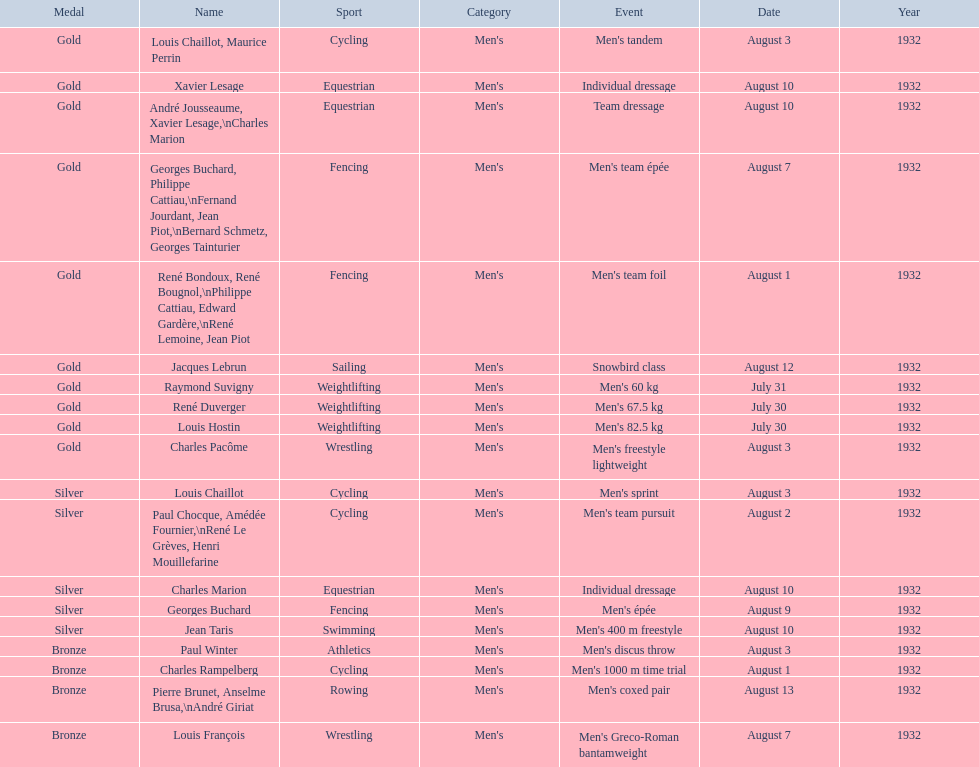How many gold medals did this country win during these olympics? 10. Would you be able to parse every entry in this table? {'header': ['Medal', 'Name', 'Sport', 'Category', 'Event', 'Date', 'Year'], 'rows': [['Gold', 'Louis Chaillot, Maurice Perrin', 'Cycling', "Men's", "Men's tandem", 'August 3', '1932'], ['Gold', 'Xavier Lesage', 'Equestrian', "Men's", 'Individual dressage', 'August 10', '1932'], ['Gold', 'André Jousseaume, Xavier Lesage,\\nCharles Marion', 'Equestrian', "Men's", 'Team dressage', 'August 10', '1932'], ['Gold', 'Georges Buchard, Philippe Cattiau,\\nFernand Jourdant, Jean Piot,\\nBernard Schmetz, Georges Tainturier', 'Fencing', "Men's", "Men's team épée", 'August 7', '1932'], ['Gold', 'René Bondoux, René Bougnol,\\nPhilippe Cattiau, Edward Gardère,\\nRené Lemoine, Jean Piot', 'Fencing', "Men's", "Men's team foil", 'August 1', '1932'], ['Gold', 'Jacques Lebrun', 'Sailing', "Men's", 'Snowbird class', 'August 12', '1932'], ['Gold', 'Raymond Suvigny', 'Weightlifting', "Men's", "Men's 60 kg", 'July 31', '1932'], ['Gold', 'René Duverger', 'Weightlifting', "Men's", "Men's 67.5 kg", 'July 30', '1932'], ['Gold', 'Louis Hostin', 'Weightlifting', "Men's", "Men's 82.5 kg", 'July 30', '1932'], ['Gold', 'Charles Pacôme', 'Wrestling', "Men's", "Men's freestyle lightweight", 'August 3', '1932'], ['Silver', 'Louis Chaillot', 'Cycling', "Men's", "Men's sprint", 'August 3', '1932'], ['Silver', 'Paul Chocque, Amédée Fournier,\\nRené Le Grèves, Henri Mouillefarine', 'Cycling', "Men's", "Men's team pursuit", 'August 2', '1932'], ['Silver', 'Charles Marion', 'Equestrian', "Men's", 'Individual dressage', 'August 10', '1932'], ['Silver', 'Georges Buchard', 'Fencing', "Men's", "Men's épée", 'August 9', '1932'], ['Silver', 'Jean Taris', 'Swimming', "Men's", "Men's 400 m freestyle", 'August 10', '1932'], ['Bronze', 'Paul Winter', 'Athletics', "Men's", "Men's discus throw", 'August 3', '1932'], ['Bronze', 'Charles Rampelberg', 'Cycling', "Men's", "Men's 1000 m time trial", 'August 1', '1932'], ['Bronze', 'Pierre Brunet, Anselme Brusa,\\nAndré Giriat', 'Rowing', "Men's", "Men's coxed pair", 'August 13', '1932'], ['Bronze', 'Louis François', 'Wrestling', "Men's", "Men's Greco-Roman bantamweight", 'August 7', '1932']]} 